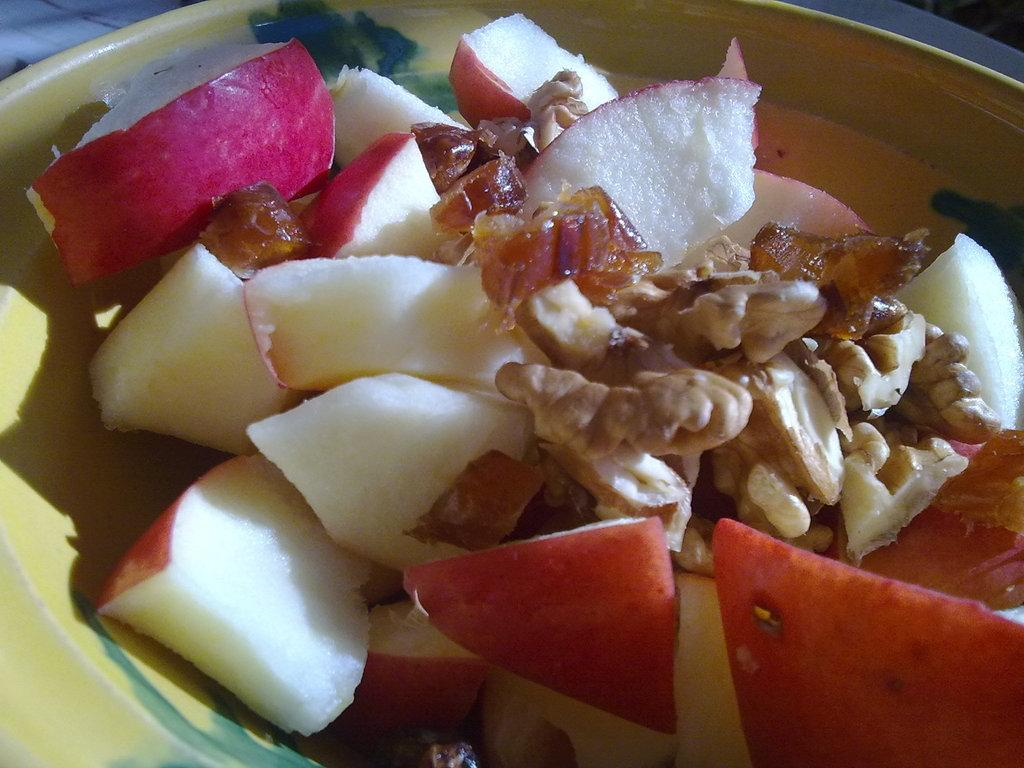What is present on the plate in the image? There is food in a plate in the image. Can you see a cactus growing on the plate in the image? No, there is no cactus present on the plate in the image. 